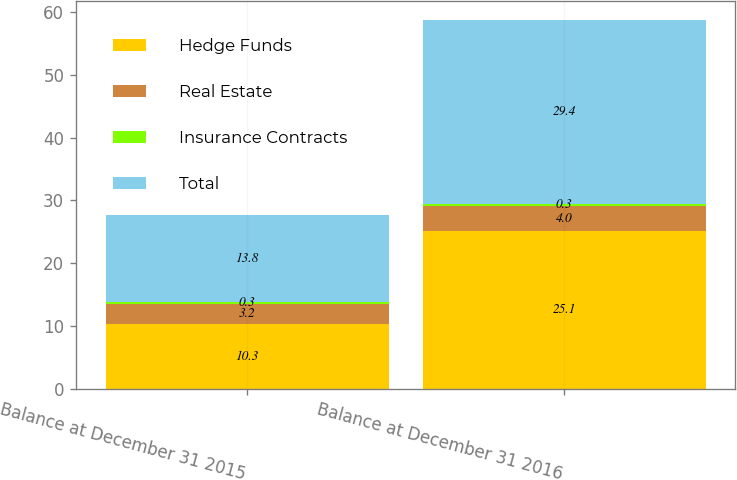Convert chart to OTSL. <chart><loc_0><loc_0><loc_500><loc_500><stacked_bar_chart><ecel><fcel>Balance at December 31 2015<fcel>Balance at December 31 2016<nl><fcel>Hedge Funds<fcel>10.3<fcel>25.1<nl><fcel>Real Estate<fcel>3.2<fcel>4<nl><fcel>Insurance Contracts<fcel>0.3<fcel>0.3<nl><fcel>Total<fcel>13.8<fcel>29.4<nl></chart> 